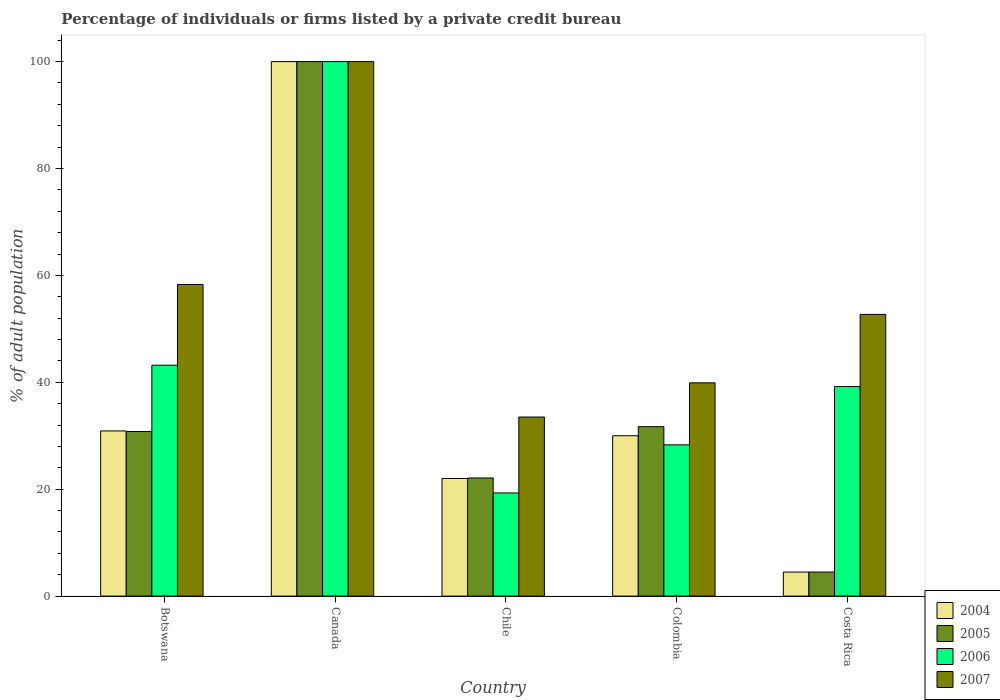How many different coloured bars are there?
Provide a succinct answer. 4. How many groups of bars are there?
Your answer should be very brief. 5. Are the number of bars per tick equal to the number of legend labels?
Offer a terse response. Yes. Are the number of bars on each tick of the X-axis equal?
Your answer should be compact. Yes. How many bars are there on the 5th tick from the right?
Keep it short and to the point. 4. What is the label of the 2nd group of bars from the left?
Ensure brevity in your answer.  Canada. What is the percentage of population listed by a private credit bureau in 2006 in Chile?
Give a very brief answer. 19.3. Across all countries, what is the maximum percentage of population listed by a private credit bureau in 2004?
Give a very brief answer. 100. Across all countries, what is the minimum percentage of population listed by a private credit bureau in 2007?
Offer a terse response. 33.5. In which country was the percentage of population listed by a private credit bureau in 2006 maximum?
Give a very brief answer. Canada. What is the total percentage of population listed by a private credit bureau in 2005 in the graph?
Offer a very short reply. 189.1. What is the difference between the percentage of population listed by a private credit bureau in 2005 in Colombia and that in Costa Rica?
Keep it short and to the point. 27.2. What is the difference between the percentage of population listed by a private credit bureau in 2007 in Chile and the percentage of population listed by a private credit bureau in 2004 in Costa Rica?
Offer a very short reply. 29. What is the average percentage of population listed by a private credit bureau in 2004 per country?
Your response must be concise. 37.48. What is the difference between the percentage of population listed by a private credit bureau of/in 2007 and percentage of population listed by a private credit bureau of/in 2006 in Botswana?
Your response must be concise. 15.1. What is the ratio of the percentage of population listed by a private credit bureau in 2006 in Botswana to that in Canada?
Give a very brief answer. 0.43. Is the percentage of population listed by a private credit bureau in 2004 in Canada less than that in Costa Rica?
Your answer should be compact. No. Is the difference between the percentage of population listed by a private credit bureau in 2007 in Canada and Costa Rica greater than the difference between the percentage of population listed by a private credit bureau in 2006 in Canada and Costa Rica?
Provide a short and direct response. No. What is the difference between the highest and the second highest percentage of population listed by a private credit bureau in 2005?
Provide a succinct answer. 69.2. What is the difference between the highest and the lowest percentage of population listed by a private credit bureau in 2007?
Offer a terse response. 66.5. In how many countries, is the percentage of population listed by a private credit bureau in 2004 greater than the average percentage of population listed by a private credit bureau in 2004 taken over all countries?
Ensure brevity in your answer.  1. Is the sum of the percentage of population listed by a private credit bureau in 2006 in Chile and Costa Rica greater than the maximum percentage of population listed by a private credit bureau in 2007 across all countries?
Your answer should be compact. No. Is it the case that in every country, the sum of the percentage of population listed by a private credit bureau in 2004 and percentage of population listed by a private credit bureau in 2005 is greater than the sum of percentage of population listed by a private credit bureau in 2007 and percentage of population listed by a private credit bureau in 2006?
Offer a very short reply. No. What does the 3rd bar from the left in Colombia represents?
Give a very brief answer. 2006. What does the 1st bar from the right in Colombia represents?
Give a very brief answer. 2007. Is it the case that in every country, the sum of the percentage of population listed by a private credit bureau in 2005 and percentage of population listed by a private credit bureau in 2006 is greater than the percentage of population listed by a private credit bureau in 2007?
Your answer should be very brief. No. Are all the bars in the graph horizontal?
Give a very brief answer. No. How many countries are there in the graph?
Make the answer very short. 5. Are the values on the major ticks of Y-axis written in scientific E-notation?
Provide a short and direct response. No. How many legend labels are there?
Provide a succinct answer. 4. What is the title of the graph?
Keep it short and to the point. Percentage of individuals or firms listed by a private credit bureau. What is the label or title of the Y-axis?
Provide a short and direct response. % of adult population. What is the % of adult population in 2004 in Botswana?
Your response must be concise. 30.9. What is the % of adult population of 2005 in Botswana?
Offer a very short reply. 30.8. What is the % of adult population of 2006 in Botswana?
Your answer should be very brief. 43.2. What is the % of adult population in 2007 in Botswana?
Make the answer very short. 58.3. What is the % of adult population of 2006 in Canada?
Keep it short and to the point. 100. What is the % of adult population in 2005 in Chile?
Offer a very short reply. 22.1. What is the % of adult population in 2006 in Chile?
Offer a terse response. 19.3. What is the % of adult population in 2007 in Chile?
Give a very brief answer. 33.5. What is the % of adult population in 2005 in Colombia?
Your response must be concise. 31.7. What is the % of adult population in 2006 in Colombia?
Give a very brief answer. 28.3. What is the % of adult population in 2007 in Colombia?
Your answer should be very brief. 39.9. What is the % of adult population of 2004 in Costa Rica?
Offer a terse response. 4.5. What is the % of adult population of 2005 in Costa Rica?
Provide a short and direct response. 4.5. What is the % of adult population in 2006 in Costa Rica?
Make the answer very short. 39.2. What is the % of adult population of 2007 in Costa Rica?
Provide a succinct answer. 52.7. Across all countries, what is the maximum % of adult population of 2005?
Offer a very short reply. 100. Across all countries, what is the maximum % of adult population in 2006?
Your answer should be very brief. 100. Across all countries, what is the minimum % of adult population of 2004?
Make the answer very short. 4.5. Across all countries, what is the minimum % of adult population in 2006?
Your response must be concise. 19.3. Across all countries, what is the minimum % of adult population of 2007?
Offer a terse response. 33.5. What is the total % of adult population of 2004 in the graph?
Ensure brevity in your answer.  187.4. What is the total % of adult population in 2005 in the graph?
Your answer should be compact. 189.1. What is the total % of adult population of 2006 in the graph?
Make the answer very short. 230. What is the total % of adult population in 2007 in the graph?
Provide a succinct answer. 284.4. What is the difference between the % of adult population of 2004 in Botswana and that in Canada?
Keep it short and to the point. -69.1. What is the difference between the % of adult population in 2005 in Botswana and that in Canada?
Keep it short and to the point. -69.2. What is the difference between the % of adult population in 2006 in Botswana and that in Canada?
Offer a terse response. -56.8. What is the difference between the % of adult population in 2007 in Botswana and that in Canada?
Provide a short and direct response. -41.7. What is the difference between the % of adult population in 2004 in Botswana and that in Chile?
Make the answer very short. 8.9. What is the difference between the % of adult population in 2006 in Botswana and that in Chile?
Give a very brief answer. 23.9. What is the difference between the % of adult population of 2007 in Botswana and that in Chile?
Ensure brevity in your answer.  24.8. What is the difference between the % of adult population in 2004 in Botswana and that in Colombia?
Offer a terse response. 0.9. What is the difference between the % of adult population in 2005 in Botswana and that in Colombia?
Offer a terse response. -0.9. What is the difference between the % of adult population in 2004 in Botswana and that in Costa Rica?
Give a very brief answer. 26.4. What is the difference between the % of adult population of 2005 in Botswana and that in Costa Rica?
Keep it short and to the point. 26.3. What is the difference between the % of adult population of 2006 in Botswana and that in Costa Rica?
Offer a terse response. 4. What is the difference between the % of adult population in 2007 in Botswana and that in Costa Rica?
Your answer should be compact. 5.6. What is the difference between the % of adult population in 2005 in Canada and that in Chile?
Give a very brief answer. 77.9. What is the difference between the % of adult population in 2006 in Canada and that in Chile?
Your answer should be compact. 80.7. What is the difference between the % of adult population in 2007 in Canada and that in Chile?
Ensure brevity in your answer.  66.5. What is the difference between the % of adult population of 2004 in Canada and that in Colombia?
Your response must be concise. 70. What is the difference between the % of adult population of 2005 in Canada and that in Colombia?
Provide a succinct answer. 68.3. What is the difference between the % of adult population of 2006 in Canada and that in Colombia?
Provide a succinct answer. 71.7. What is the difference between the % of adult population in 2007 in Canada and that in Colombia?
Provide a short and direct response. 60.1. What is the difference between the % of adult population in 2004 in Canada and that in Costa Rica?
Your answer should be very brief. 95.5. What is the difference between the % of adult population of 2005 in Canada and that in Costa Rica?
Give a very brief answer. 95.5. What is the difference between the % of adult population of 2006 in Canada and that in Costa Rica?
Offer a terse response. 60.8. What is the difference between the % of adult population in 2007 in Canada and that in Costa Rica?
Your answer should be compact. 47.3. What is the difference between the % of adult population of 2005 in Chile and that in Colombia?
Make the answer very short. -9.6. What is the difference between the % of adult population in 2004 in Chile and that in Costa Rica?
Make the answer very short. 17.5. What is the difference between the % of adult population of 2006 in Chile and that in Costa Rica?
Your response must be concise. -19.9. What is the difference between the % of adult population in 2007 in Chile and that in Costa Rica?
Provide a short and direct response. -19.2. What is the difference between the % of adult population of 2005 in Colombia and that in Costa Rica?
Provide a short and direct response. 27.2. What is the difference between the % of adult population in 2007 in Colombia and that in Costa Rica?
Provide a succinct answer. -12.8. What is the difference between the % of adult population of 2004 in Botswana and the % of adult population of 2005 in Canada?
Your answer should be very brief. -69.1. What is the difference between the % of adult population of 2004 in Botswana and the % of adult population of 2006 in Canada?
Ensure brevity in your answer.  -69.1. What is the difference between the % of adult population of 2004 in Botswana and the % of adult population of 2007 in Canada?
Keep it short and to the point. -69.1. What is the difference between the % of adult population in 2005 in Botswana and the % of adult population in 2006 in Canada?
Give a very brief answer. -69.2. What is the difference between the % of adult population in 2005 in Botswana and the % of adult population in 2007 in Canada?
Offer a terse response. -69.2. What is the difference between the % of adult population in 2006 in Botswana and the % of adult population in 2007 in Canada?
Make the answer very short. -56.8. What is the difference between the % of adult population of 2004 in Botswana and the % of adult population of 2005 in Colombia?
Offer a terse response. -0.8. What is the difference between the % of adult population of 2004 in Botswana and the % of adult population of 2006 in Colombia?
Provide a short and direct response. 2.6. What is the difference between the % of adult population of 2004 in Botswana and the % of adult population of 2007 in Colombia?
Offer a very short reply. -9. What is the difference between the % of adult population in 2004 in Botswana and the % of adult population in 2005 in Costa Rica?
Offer a very short reply. 26.4. What is the difference between the % of adult population in 2004 in Botswana and the % of adult population in 2006 in Costa Rica?
Your response must be concise. -8.3. What is the difference between the % of adult population of 2004 in Botswana and the % of adult population of 2007 in Costa Rica?
Offer a terse response. -21.8. What is the difference between the % of adult population in 2005 in Botswana and the % of adult population in 2006 in Costa Rica?
Make the answer very short. -8.4. What is the difference between the % of adult population of 2005 in Botswana and the % of adult population of 2007 in Costa Rica?
Your answer should be compact. -21.9. What is the difference between the % of adult population of 2006 in Botswana and the % of adult population of 2007 in Costa Rica?
Ensure brevity in your answer.  -9.5. What is the difference between the % of adult population in 2004 in Canada and the % of adult population in 2005 in Chile?
Make the answer very short. 77.9. What is the difference between the % of adult population of 2004 in Canada and the % of adult population of 2006 in Chile?
Your answer should be compact. 80.7. What is the difference between the % of adult population in 2004 in Canada and the % of adult population in 2007 in Chile?
Offer a very short reply. 66.5. What is the difference between the % of adult population in 2005 in Canada and the % of adult population in 2006 in Chile?
Keep it short and to the point. 80.7. What is the difference between the % of adult population of 2005 in Canada and the % of adult population of 2007 in Chile?
Ensure brevity in your answer.  66.5. What is the difference between the % of adult population in 2006 in Canada and the % of adult population in 2007 in Chile?
Make the answer very short. 66.5. What is the difference between the % of adult population in 2004 in Canada and the % of adult population in 2005 in Colombia?
Keep it short and to the point. 68.3. What is the difference between the % of adult population in 2004 in Canada and the % of adult population in 2006 in Colombia?
Provide a short and direct response. 71.7. What is the difference between the % of adult population in 2004 in Canada and the % of adult population in 2007 in Colombia?
Your answer should be very brief. 60.1. What is the difference between the % of adult population in 2005 in Canada and the % of adult population in 2006 in Colombia?
Give a very brief answer. 71.7. What is the difference between the % of adult population in 2005 in Canada and the % of adult population in 2007 in Colombia?
Keep it short and to the point. 60.1. What is the difference between the % of adult population in 2006 in Canada and the % of adult population in 2007 in Colombia?
Provide a succinct answer. 60.1. What is the difference between the % of adult population of 2004 in Canada and the % of adult population of 2005 in Costa Rica?
Your response must be concise. 95.5. What is the difference between the % of adult population in 2004 in Canada and the % of adult population in 2006 in Costa Rica?
Your response must be concise. 60.8. What is the difference between the % of adult population of 2004 in Canada and the % of adult population of 2007 in Costa Rica?
Your response must be concise. 47.3. What is the difference between the % of adult population in 2005 in Canada and the % of adult population in 2006 in Costa Rica?
Your answer should be very brief. 60.8. What is the difference between the % of adult population of 2005 in Canada and the % of adult population of 2007 in Costa Rica?
Ensure brevity in your answer.  47.3. What is the difference between the % of adult population in 2006 in Canada and the % of adult population in 2007 in Costa Rica?
Offer a terse response. 47.3. What is the difference between the % of adult population of 2004 in Chile and the % of adult population of 2005 in Colombia?
Ensure brevity in your answer.  -9.7. What is the difference between the % of adult population of 2004 in Chile and the % of adult population of 2006 in Colombia?
Give a very brief answer. -6.3. What is the difference between the % of adult population of 2004 in Chile and the % of adult population of 2007 in Colombia?
Provide a succinct answer. -17.9. What is the difference between the % of adult population of 2005 in Chile and the % of adult population of 2007 in Colombia?
Keep it short and to the point. -17.8. What is the difference between the % of adult population of 2006 in Chile and the % of adult population of 2007 in Colombia?
Ensure brevity in your answer.  -20.6. What is the difference between the % of adult population of 2004 in Chile and the % of adult population of 2005 in Costa Rica?
Make the answer very short. 17.5. What is the difference between the % of adult population in 2004 in Chile and the % of adult population in 2006 in Costa Rica?
Ensure brevity in your answer.  -17.2. What is the difference between the % of adult population in 2004 in Chile and the % of adult population in 2007 in Costa Rica?
Your answer should be very brief. -30.7. What is the difference between the % of adult population in 2005 in Chile and the % of adult population in 2006 in Costa Rica?
Your answer should be compact. -17.1. What is the difference between the % of adult population of 2005 in Chile and the % of adult population of 2007 in Costa Rica?
Offer a terse response. -30.6. What is the difference between the % of adult population of 2006 in Chile and the % of adult population of 2007 in Costa Rica?
Give a very brief answer. -33.4. What is the difference between the % of adult population of 2004 in Colombia and the % of adult population of 2005 in Costa Rica?
Make the answer very short. 25.5. What is the difference between the % of adult population of 2004 in Colombia and the % of adult population of 2006 in Costa Rica?
Make the answer very short. -9.2. What is the difference between the % of adult population of 2004 in Colombia and the % of adult population of 2007 in Costa Rica?
Your answer should be compact. -22.7. What is the difference between the % of adult population in 2005 in Colombia and the % of adult population in 2006 in Costa Rica?
Your response must be concise. -7.5. What is the difference between the % of adult population in 2006 in Colombia and the % of adult population in 2007 in Costa Rica?
Your response must be concise. -24.4. What is the average % of adult population of 2004 per country?
Ensure brevity in your answer.  37.48. What is the average % of adult population in 2005 per country?
Offer a terse response. 37.82. What is the average % of adult population in 2007 per country?
Keep it short and to the point. 56.88. What is the difference between the % of adult population in 2004 and % of adult population in 2007 in Botswana?
Keep it short and to the point. -27.4. What is the difference between the % of adult population of 2005 and % of adult population of 2006 in Botswana?
Provide a short and direct response. -12.4. What is the difference between the % of adult population of 2005 and % of adult population of 2007 in Botswana?
Provide a short and direct response. -27.5. What is the difference between the % of adult population of 2006 and % of adult population of 2007 in Botswana?
Your response must be concise. -15.1. What is the difference between the % of adult population in 2004 and % of adult population in 2005 in Canada?
Make the answer very short. 0. What is the difference between the % of adult population of 2005 and % of adult population of 2007 in Canada?
Ensure brevity in your answer.  0. What is the difference between the % of adult population in 2004 and % of adult population in 2005 in Chile?
Keep it short and to the point. -0.1. What is the difference between the % of adult population in 2004 and % of adult population in 2006 in Chile?
Your response must be concise. 2.7. What is the difference between the % of adult population of 2005 and % of adult population of 2006 in Chile?
Provide a short and direct response. 2.8. What is the difference between the % of adult population of 2005 and % of adult population of 2007 in Chile?
Your answer should be very brief. -11.4. What is the difference between the % of adult population in 2006 and % of adult population in 2007 in Chile?
Offer a terse response. -14.2. What is the difference between the % of adult population in 2004 and % of adult population in 2005 in Colombia?
Offer a terse response. -1.7. What is the difference between the % of adult population of 2004 and % of adult population of 2007 in Colombia?
Your answer should be compact. -9.9. What is the difference between the % of adult population in 2006 and % of adult population in 2007 in Colombia?
Your response must be concise. -11.6. What is the difference between the % of adult population of 2004 and % of adult population of 2005 in Costa Rica?
Provide a short and direct response. 0. What is the difference between the % of adult population of 2004 and % of adult population of 2006 in Costa Rica?
Ensure brevity in your answer.  -34.7. What is the difference between the % of adult population in 2004 and % of adult population in 2007 in Costa Rica?
Your response must be concise. -48.2. What is the difference between the % of adult population in 2005 and % of adult population in 2006 in Costa Rica?
Provide a short and direct response. -34.7. What is the difference between the % of adult population in 2005 and % of adult population in 2007 in Costa Rica?
Offer a very short reply. -48.2. What is the ratio of the % of adult population of 2004 in Botswana to that in Canada?
Ensure brevity in your answer.  0.31. What is the ratio of the % of adult population in 2005 in Botswana to that in Canada?
Keep it short and to the point. 0.31. What is the ratio of the % of adult population of 2006 in Botswana to that in Canada?
Offer a very short reply. 0.43. What is the ratio of the % of adult population in 2007 in Botswana to that in Canada?
Ensure brevity in your answer.  0.58. What is the ratio of the % of adult population in 2004 in Botswana to that in Chile?
Ensure brevity in your answer.  1.4. What is the ratio of the % of adult population of 2005 in Botswana to that in Chile?
Offer a terse response. 1.39. What is the ratio of the % of adult population in 2006 in Botswana to that in Chile?
Your answer should be very brief. 2.24. What is the ratio of the % of adult population of 2007 in Botswana to that in Chile?
Make the answer very short. 1.74. What is the ratio of the % of adult population of 2004 in Botswana to that in Colombia?
Make the answer very short. 1.03. What is the ratio of the % of adult population of 2005 in Botswana to that in Colombia?
Keep it short and to the point. 0.97. What is the ratio of the % of adult population of 2006 in Botswana to that in Colombia?
Provide a succinct answer. 1.53. What is the ratio of the % of adult population in 2007 in Botswana to that in Colombia?
Provide a succinct answer. 1.46. What is the ratio of the % of adult population in 2004 in Botswana to that in Costa Rica?
Provide a succinct answer. 6.87. What is the ratio of the % of adult population in 2005 in Botswana to that in Costa Rica?
Provide a short and direct response. 6.84. What is the ratio of the % of adult population of 2006 in Botswana to that in Costa Rica?
Your response must be concise. 1.1. What is the ratio of the % of adult population of 2007 in Botswana to that in Costa Rica?
Offer a terse response. 1.11. What is the ratio of the % of adult population of 2004 in Canada to that in Chile?
Your answer should be compact. 4.55. What is the ratio of the % of adult population of 2005 in Canada to that in Chile?
Ensure brevity in your answer.  4.52. What is the ratio of the % of adult population in 2006 in Canada to that in Chile?
Offer a terse response. 5.18. What is the ratio of the % of adult population of 2007 in Canada to that in Chile?
Ensure brevity in your answer.  2.99. What is the ratio of the % of adult population in 2005 in Canada to that in Colombia?
Give a very brief answer. 3.15. What is the ratio of the % of adult population in 2006 in Canada to that in Colombia?
Ensure brevity in your answer.  3.53. What is the ratio of the % of adult population of 2007 in Canada to that in Colombia?
Your answer should be very brief. 2.51. What is the ratio of the % of adult population of 2004 in Canada to that in Costa Rica?
Keep it short and to the point. 22.22. What is the ratio of the % of adult population of 2005 in Canada to that in Costa Rica?
Make the answer very short. 22.22. What is the ratio of the % of adult population in 2006 in Canada to that in Costa Rica?
Make the answer very short. 2.55. What is the ratio of the % of adult population of 2007 in Canada to that in Costa Rica?
Offer a very short reply. 1.9. What is the ratio of the % of adult population in 2004 in Chile to that in Colombia?
Offer a terse response. 0.73. What is the ratio of the % of adult population in 2005 in Chile to that in Colombia?
Keep it short and to the point. 0.7. What is the ratio of the % of adult population in 2006 in Chile to that in Colombia?
Provide a short and direct response. 0.68. What is the ratio of the % of adult population in 2007 in Chile to that in Colombia?
Ensure brevity in your answer.  0.84. What is the ratio of the % of adult population of 2004 in Chile to that in Costa Rica?
Provide a succinct answer. 4.89. What is the ratio of the % of adult population of 2005 in Chile to that in Costa Rica?
Your response must be concise. 4.91. What is the ratio of the % of adult population of 2006 in Chile to that in Costa Rica?
Your answer should be very brief. 0.49. What is the ratio of the % of adult population of 2007 in Chile to that in Costa Rica?
Provide a succinct answer. 0.64. What is the ratio of the % of adult population in 2005 in Colombia to that in Costa Rica?
Keep it short and to the point. 7.04. What is the ratio of the % of adult population of 2006 in Colombia to that in Costa Rica?
Offer a very short reply. 0.72. What is the ratio of the % of adult population in 2007 in Colombia to that in Costa Rica?
Your answer should be very brief. 0.76. What is the difference between the highest and the second highest % of adult population of 2004?
Provide a succinct answer. 69.1. What is the difference between the highest and the second highest % of adult population in 2005?
Ensure brevity in your answer.  68.3. What is the difference between the highest and the second highest % of adult population of 2006?
Offer a terse response. 56.8. What is the difference between the highest and the second highest % of adult population of 2007?
Your answer should be compact. 41.7. What is the difference between the highest and the lowest % of adult population of 2004?
Offer a very short reply. 95.5. What is the difference between the highest and the lowest % of adult population in 2005?
Offer a very short reply. 95.5. What is the difference between the highest and the lowest % of adult population of 2006?
Offer a terse response. 80.7. What is the difference between the highest and the lowest % of adult population in 2007?
Your answer should be compact. 66.5. 